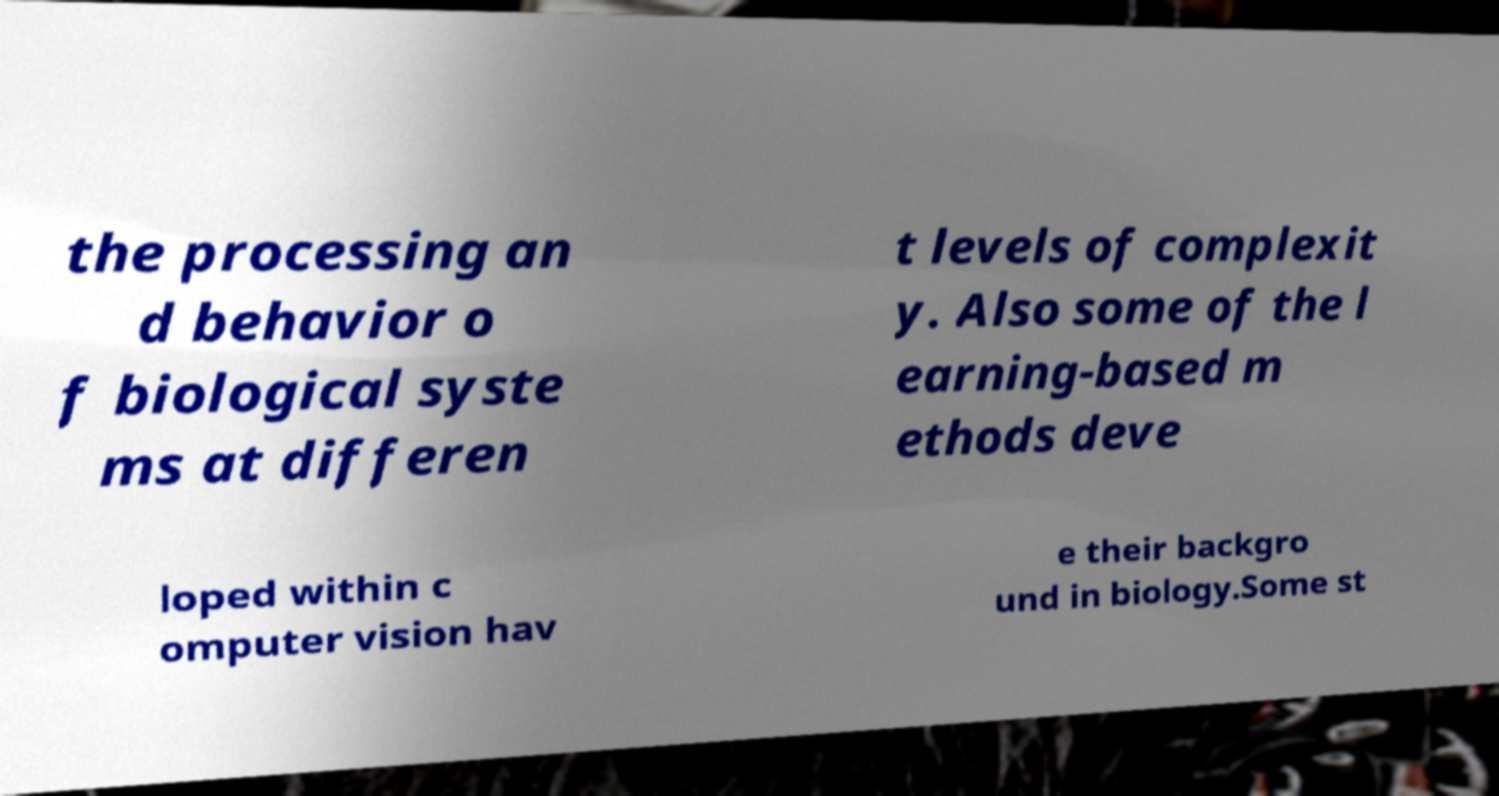For documentation purposes, I need the text within this image transcribed. Could you provide that? the processing an d behavior o f biological syste ms at differen t levels of complexit y. Also some of the l earning-based m ethods deve loped within c omputer vision hav e their backgro und in biology.Some st 